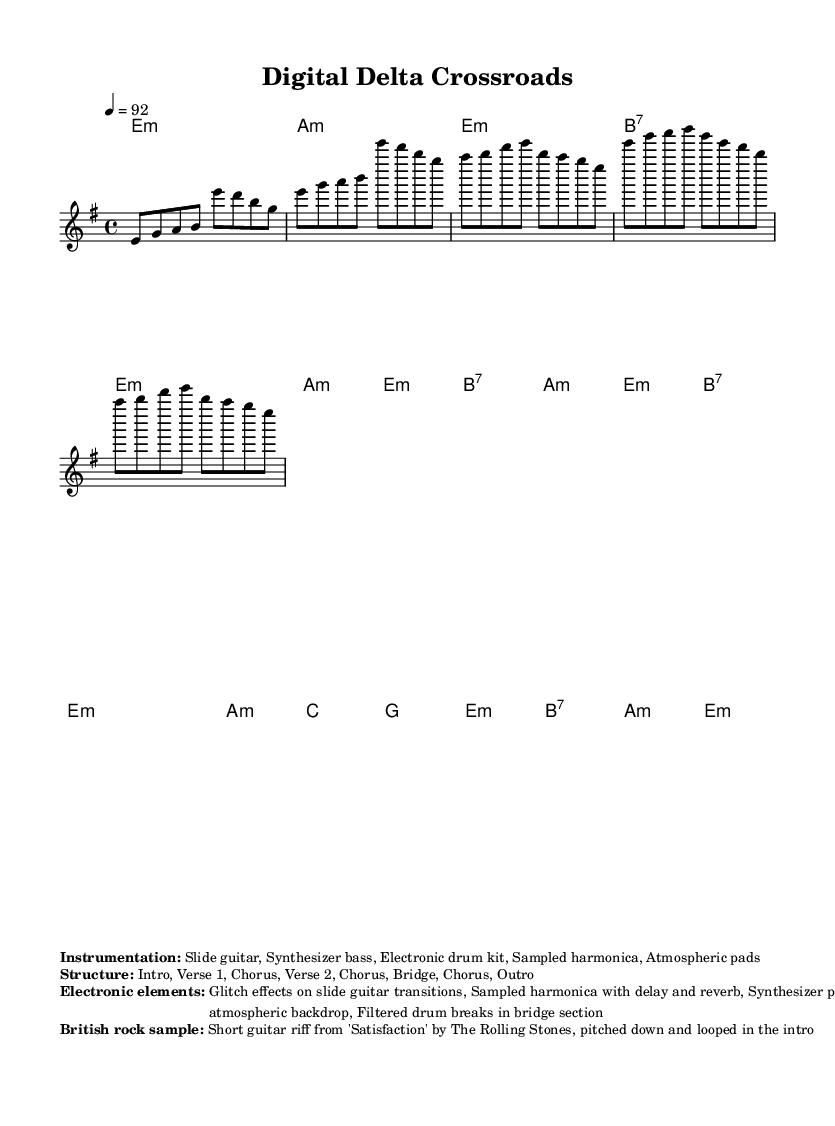What is the key signature of this music? The key signature is E minor, which has one sharp (F#). This is indicated in the global settings of the score.
Answer: E minor What is the time signature of the piece? The time signature is 4/4, indicated in the global settings. It shows that there are four beats in each measure.
Answer: 4/4 What is the tempo marking in the score? The tempo marking in the score is 92 beats per minute, specified in the global section and set for the piece.
Answer: 92 What instruments are used in the instrumentation? The instrumentation includes slide guitar, synthesizer bass, electronic drum kit, sampled harmonica, and atmospheric pads, provided in the markup section of the score.
Answer: Slide guitar, Synthesizer bass, Electronic drum kit, Sampled harmonica, Atmospheric pads How many sections are in the structure of the piece? The structure includes eight sections: Intro, Verse 1, Chorus, Verse 2, Chorus, Bridge, Chorus, and Outro, which is detailed in the structural markup.
Answer: Eight Which British rock song is sampled in the track? The sampled British rock song is 'Satisfaction' by The Rolling Stones, as noted in the electronic elements section of the markup.
Answer: Satisfaction What electronic elements are used in the music? The electronic elements consist of glitch effects on the slide guitar transitions, sampled harmonica with delay and reverb, synthesizer pads creating an atmospheric backdrop, and filtered drum breaks in the bridge section, all listed in the markup.
Answer: Glitch effects, Sampled harmonica, Synthesizer pads, Filtered drum breaks 